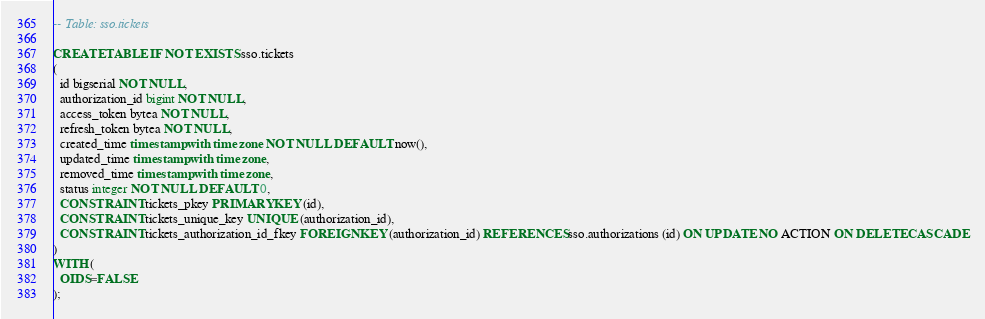Convert code to text. <code><loc_0><loc_0><loc_500><loc_500><_SQL_>-- Table: sso.tickets

CREATE TABLE IF NOT EXISTS sso.tickets
(
  id bigserial NOT NULL,
  authorization_id bigint NOT NULL,
  access_token bytea NOT NULL,
  refresh_token bytea NOT NULL,
  created_time timestamp with time zone NOT NULL DEFAULT now(),
  updated_time timestamp with time zone,
  removed_time timestamp with time zone,
  status integer NOT NULL DEFAULT 0,
  CONSTRAINT tickets_pkey PRIMARY KEY (id),
  CONSTRAINT tickets_unique_key UNIQUE (authorization_id),
  CONSTRAINT tickets_authorization_id_fkey FOREIGN KEY (authorization_id) REFERENCES sso.authorizations (id) ON UPDATE NO ACTION ON DELETE CASCADE
)
WITH (
  OIDS=FALSE
);</code> 